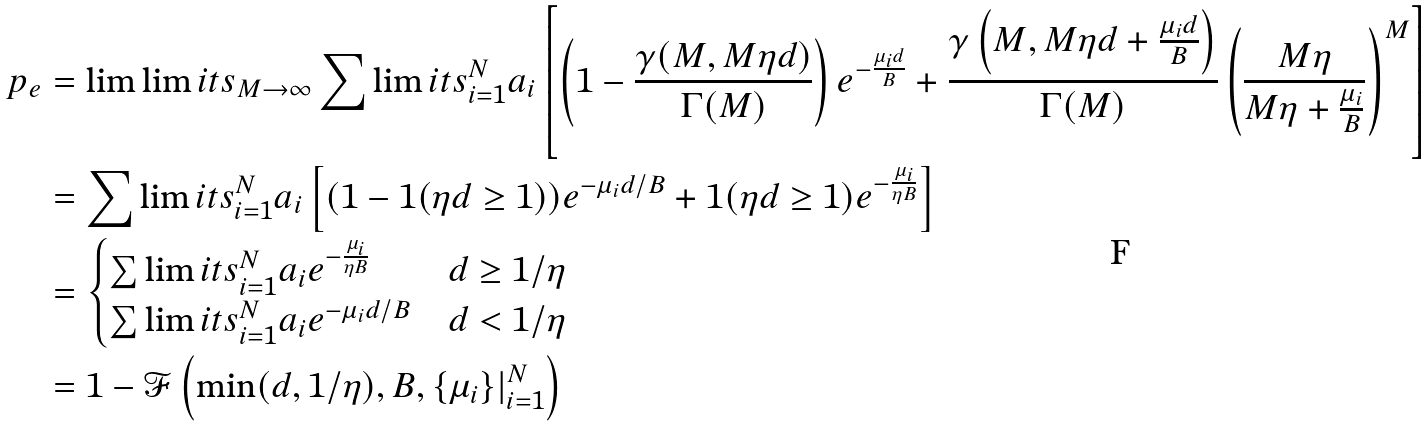Convert formula to latex. <formula><loc_0><loc_0><loc_500><loc_500>p _ { e } & = \lim \lim i t s _ { M \rightarrow \infty } \sum \lim i t s _ { i = 1 } ^ { N } a _ { i } \left [ \left ( 1 - \frac { \gamma ( M , M \eta d ) } { \Gamma ( M ) } \right ) e ^ { - \frac { \mu _ { i } d } { B } } + \frac { \gamma \left ( M , M \eta d + \frac { \mu _ { i } d } { B } \right ) } { \Gamma ( M ) } \left ( \frac { M \eta } { M \eta + \frac { \mu _ { i } } { B } } \right ) ^ { M } \right ] \\ & = \sum \lim i t s _ { i = 1 } ^ { N } a _ { i } \left [ ( 1 - 1 ( \eta d \geq 1 ) ) e ^ { - \mu _ { i } d / B } + 1 ( \eta d \geq 1 ) e ^ { - \frac { \mu _ { i } } { \eta B } } \right ] \\ & = \begin{cases} \sum \lim i t s _ { i = 1 } ^ { N } a _ { i } e ^ { - \frac { \mu _ { i } } { \eta B } } & d \geq 1 / \eta \\ \sum \lim i t s _ { i = 1 } ^ { N } a _ { i } e ^ { - \mu _ { i } d / B } & d < 1 / \eta \\ \end{cases} \\ & = 1 - \mathcal { F } \left ( \min ( d , 1 / \eta ) , B , \{ \mu _ { i } \} | _ { i = 1 } ^ { N } \right )</formula> 